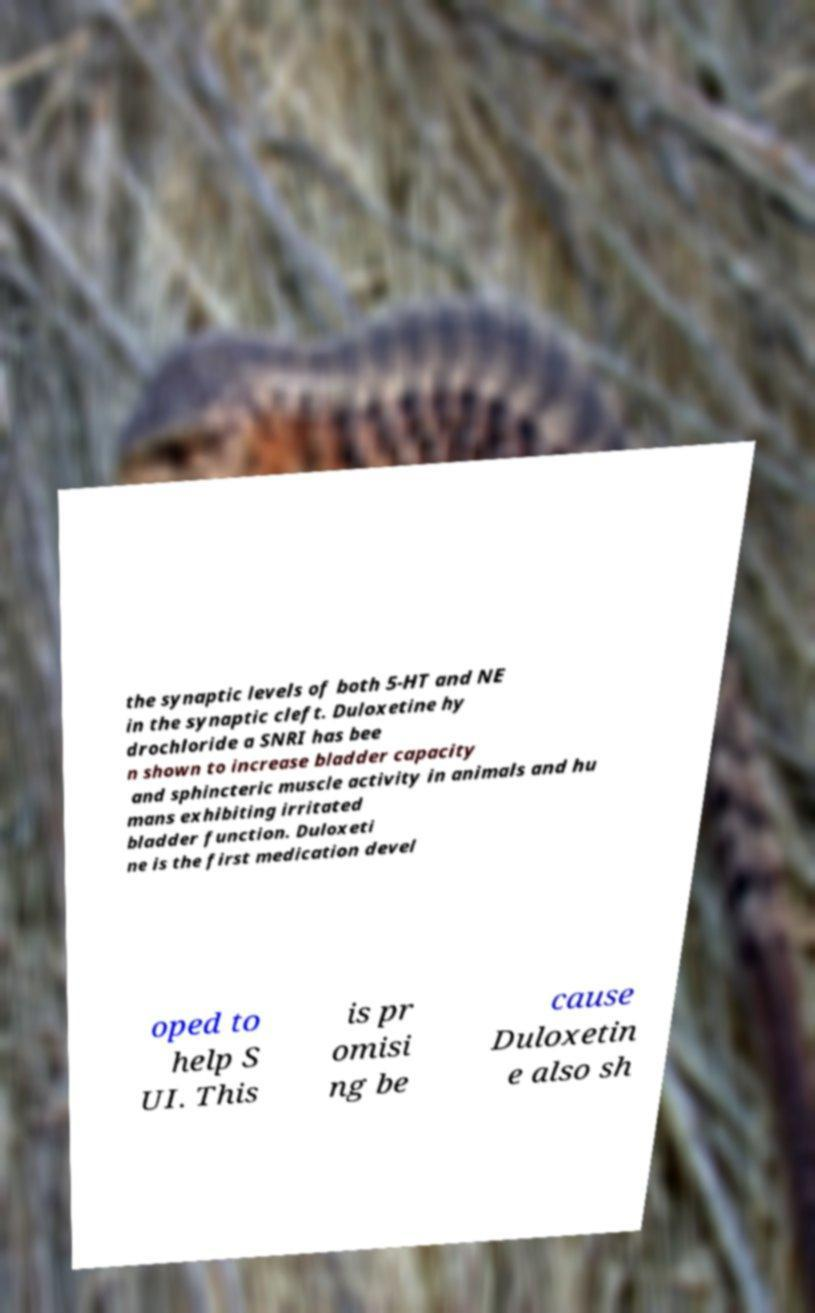For documentation purposes, I need the text within this image transcribed. Could you provide that? the synaptic levels of both 5-HT and NE in the synaptic cleft. Duloxetine hy drochloride a SNRI has bee n shown to increase bladder capacity and sphincteric muscle activity in animals and hu mans exhibiting irritated bladder function. Duloxeti ne is the first medication devel oped to help S UI. This is pr omisi ng be cause Duloxetin e also sh 